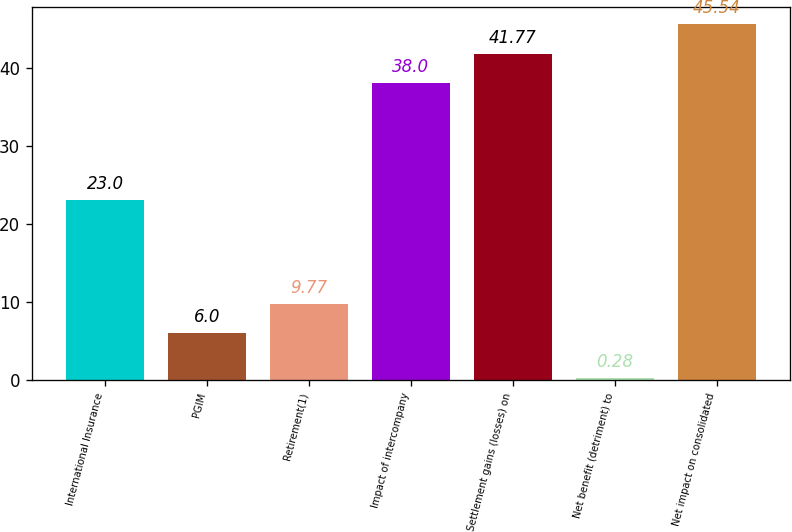<chart> <loc_0><loc_0><loc_500><loc_500><bar_chart><fcel>International Insurance<fcel>PGIM<fcel>Retirement(1)<fcel>Impact of intercompany<fcel>Settlement gains (losses) on<fcel>Net benefit (detriment) to<fcel>Net impact on consolidated<nl><fcel>23<fcel>6<fcel>9.77<fcel>38<fcel>41.77<fcel>0.28<fcel>45.54<nl></chart> 